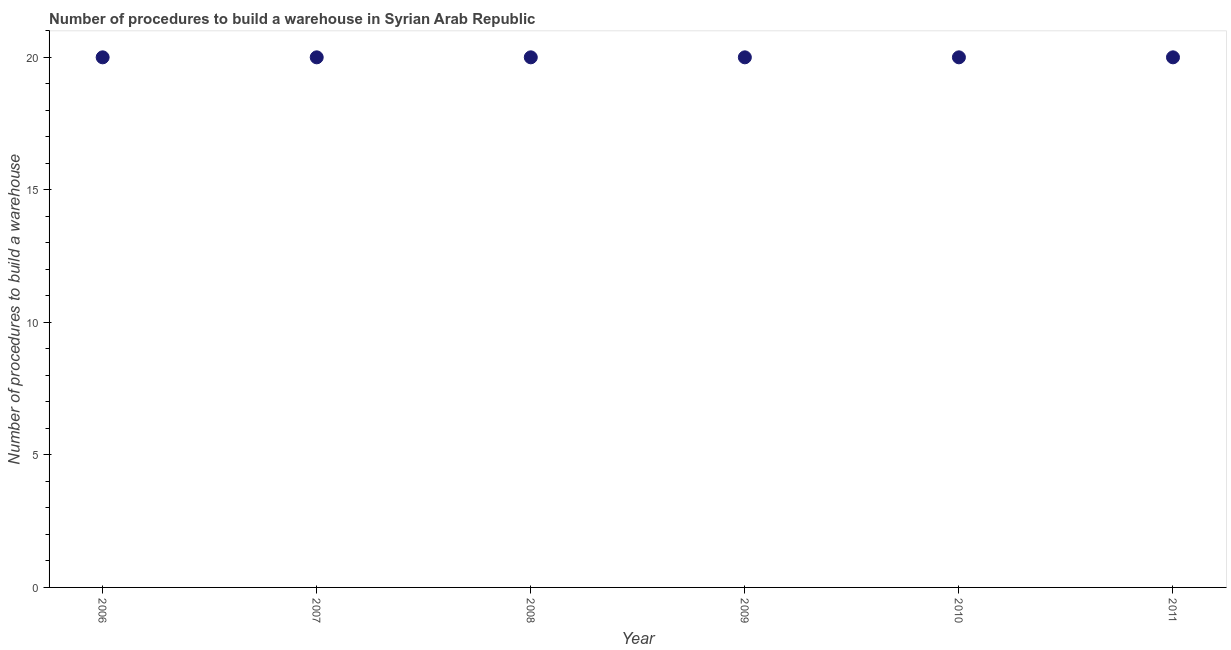What is the number of procedures to build a warehouse in 2010?
Your answer should be very brief. 20. Across all years, what is the maximum number of procedures to build a warehouse?
Keep it short and to the point. 20. Across all years, what is the minimum number of procedures to build a warehouse?
Your answer should be compact. 20. In which year was the number of procedures to build a warehouse maximum?
Ensure brevity in your answer.  2006. In which year was the number of procedures to build a warehouse minimum?
Provide a short and direct response. 2006. What is the sum of the number of procedures to build a warehouse?
Your response must be concise. 120. What is the median number of procedures to build a warehouse?
Your response must be concise. 20. In how many years, is the number of procedures to build a warehouse greater than 19 ?
Keep it short and to the point. 6. Do a majority of the years between 2009 and 2007 (inclusive) have number of procedures to build a warehouse greater than 11 ?
Your response must be concise. No. Is the number of procedures to build a warehouse in 2007 less than that in 2011?
Your answer should be compact. No. Is the difference between the number of procedures to build a warehouse in 2009 and 2010 greater than the difference between any two years?
Provide a short and direct response. Yes. What is the difference between the highest and the second highest number of procedures to build a warehouse?
Your answer should be very brief. 0. What is the difference between the highest and the lowest number of procedures to build a warehouse?
Ensure brevity in your answer.  0. In how many years, is the number of procedures to build a warehouse greater than the average number of procedures to build a warehouse taken over all years?
Provide a succinct answer. 0. How many years are there in the graph?
Make the answer very short. 6. What is the title of the graph?
Your response must be concise. Number of procedures to build a warehouse in Syrian Arab Republic. What is the label or title of the Y-axis?
Offer a very short reply. Number of procedures to build a warehouse. What is the Number of procedures to build a warehouse in 2007?
Keep it short and to the point. 20. What is the Number of procedures to build a warehouse in 2008?
Provide a short and direct response. 20. What is the Number of procedures to build a warehouse in 2009?
Your response must be concise. 20. What is the Number of procedures to build a warehouse in 2010?
Your response must be concise. 20. What is the difference between the Number of procedures to build a warehouse in 2006 and 2007?
Provide a short and direct response. 0. What is the difference between the Number of procedures to build a warehouse in 2006 and 2010?
Give a very brief answer. 0. What is the difference between the Number of procedures to build a warehouse in 2007 and 2010?
Offer a very short reply. 0. What is the difference between the Number of procedures to build a warehouse in 2008 and 2010?
Offer a terse response. 0. What is the difference between the Number of procedures to build a warehouse in 2009 and 2011?
Make the answer very short. 0. What is the ratio of the Number of procedures to build a warehouse in 2006 to that in 2009?
Provide a short and direct response. 1. What is the ratio of the Number of procedures to build a warehouse in 2007 to that in 2008?
Give a very brief answer. 1. What is the ratio of the Number of procedures to build a warehouse in 2007 to that in 2009?
Offer a very short reply. 1. What is the ratio of the Number of procedures to build a warehouse in 2008 to that in 2010?
Your response must be concise. 1. What is the ratio of the Number of procedures to build a warehouse in 2009 to that in 2010?
Offer a very short reply. 1. What is the ratio of the Number of procedures to build a warehouse in 2010 to that in 2011?
Provide a short and direct response. 1. 